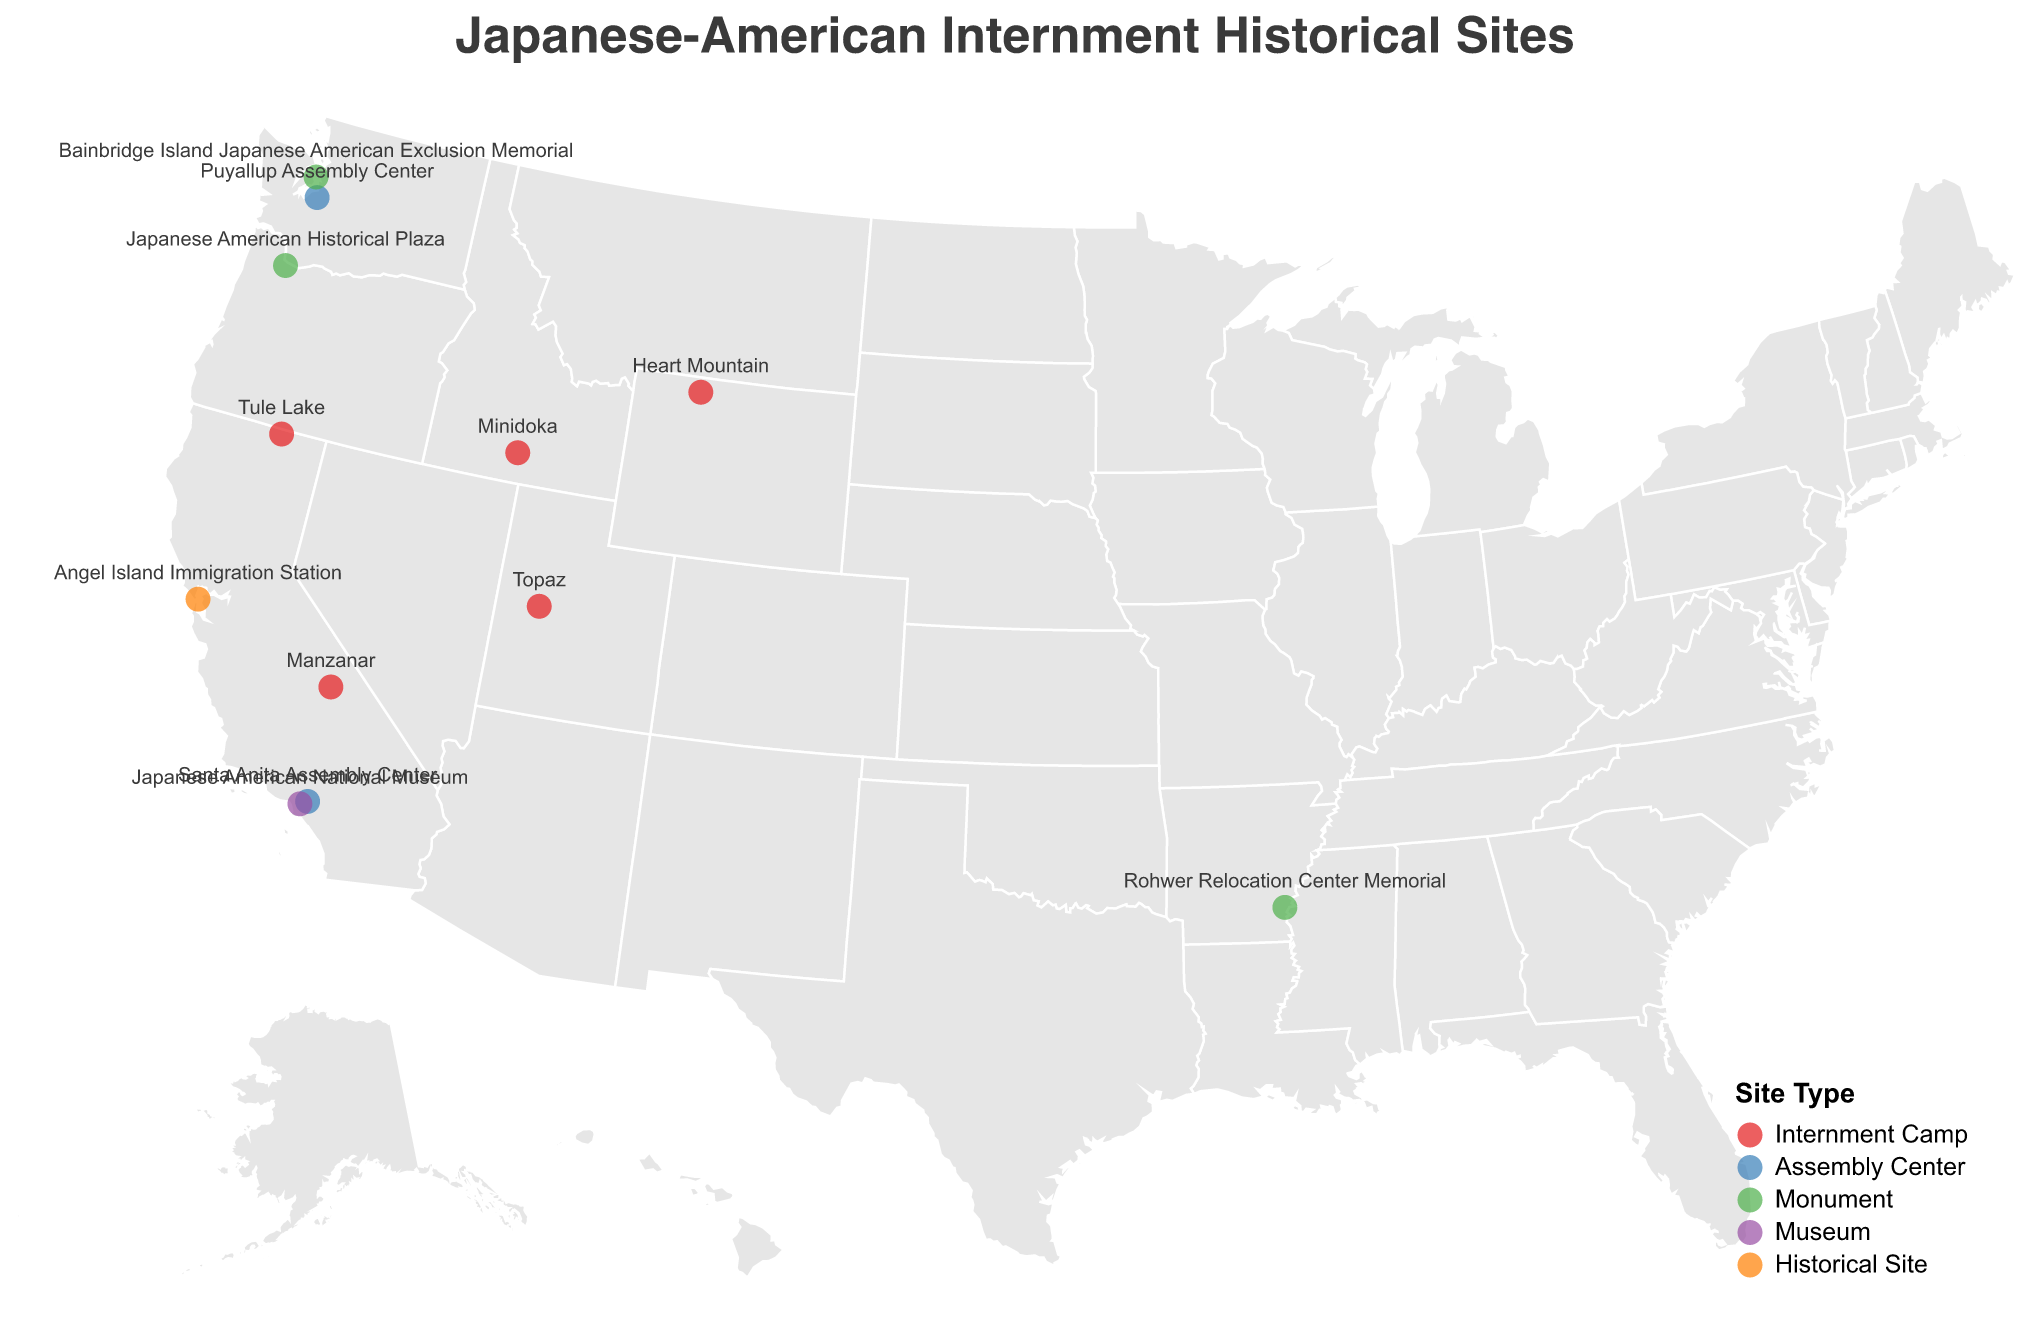What is the title of the plot? The title is written at the top of the plot and describes the main focus of the visual
Answer: Japanese-American Internment Historical Sites How many internment camps are shown on the plot? In the legend, the sites are categorized by type and colored differently, making it easier to count the "Internment Camp" category.
Answer: 5 Which site is the northernmost? By examining the latitude values of each point, the site with the highest latitude will be the northernmost.
Answer: Puyallup Assembly Center What color represents monuments on the plot? The legend at the bottom-right corner of the plot shows the colors used for each type of site.
Answer: Green Which historical site is located closest to Los Angeles? By looking at the sites in proximity to Los Angeles on the map, you can determine the closest one based on its longitude and latitude.
Answer: Japanese American National Museum How many points on the plot represent assembly centers? Looking at the legend, you see that assembly centers are represented by a specific color. Count the number of points in that color.
Answer: 2 What is the site type of Manzanar? Hovering over or looking at the labels next to the points, you can find Manzanar and see its type.
Answer: Internment Camp Which site is the westernmost monument? The site with the lowest longitude value in the "Monument" category will be the westernmost.
Answer: Bainbridge Island Japanese American Exclusion Memorial Are there more internment camps or monuments on the plot? Count the number of points for each type based on the legend colors and compare the totals.
Answer: Internment camps Where is the Angel Island Immigration Station located? Refer to the label on the plot to find its geographic coordinates, noting that it’s a historical site.
Answer: 37.8663, -122.4322 